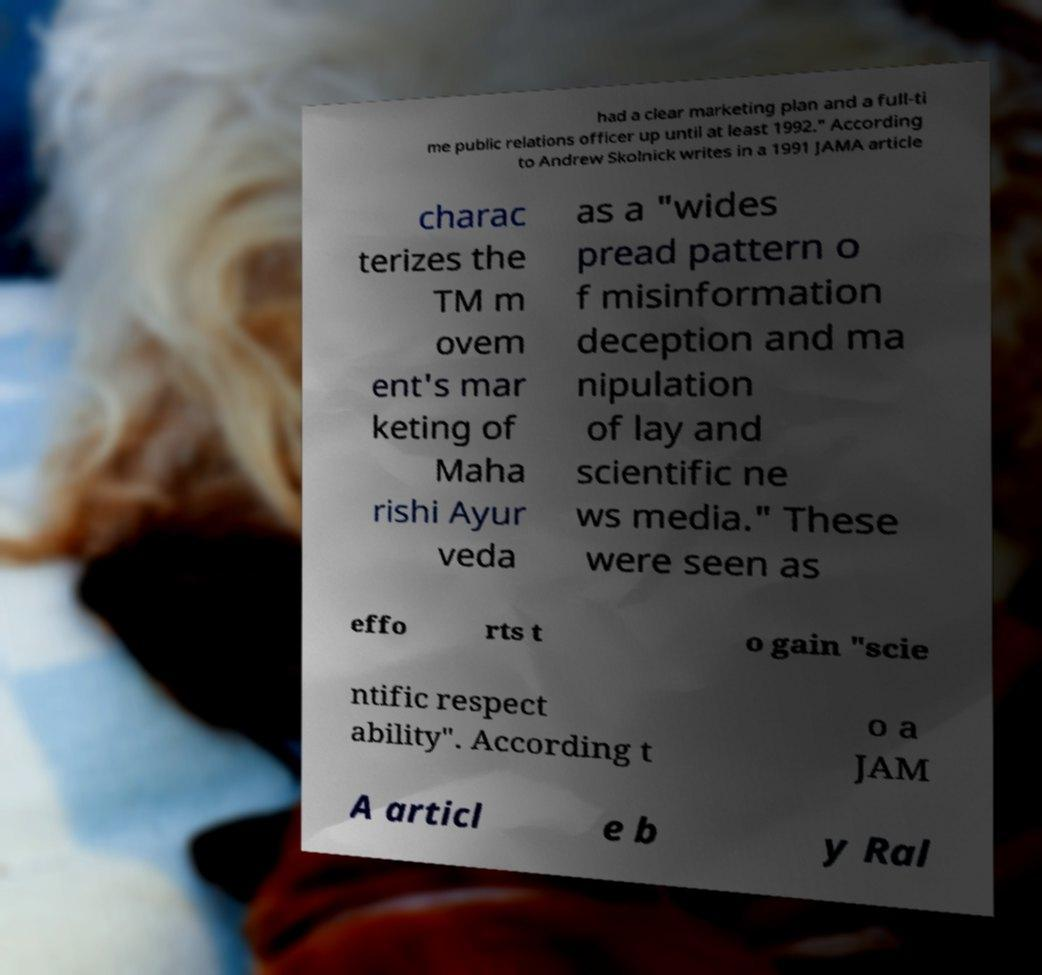I need the written content from this picture converted into text. Can you do that? had a clear marketing plan and a full-ti me public relations officer up until at least 1992." According to Andrew Skolnick writes in a 1991 JAMA article charac terizes the TM m ovem ent's mar keting of Maha rishi Ayur veda as a "wides pread pattern o f misinformation deception and ma nipulation of lay and scientific ne ws media." These were seen as effo rts t o gain "scie ntific respect ability". According t o a JAM A articl e b y Ral 